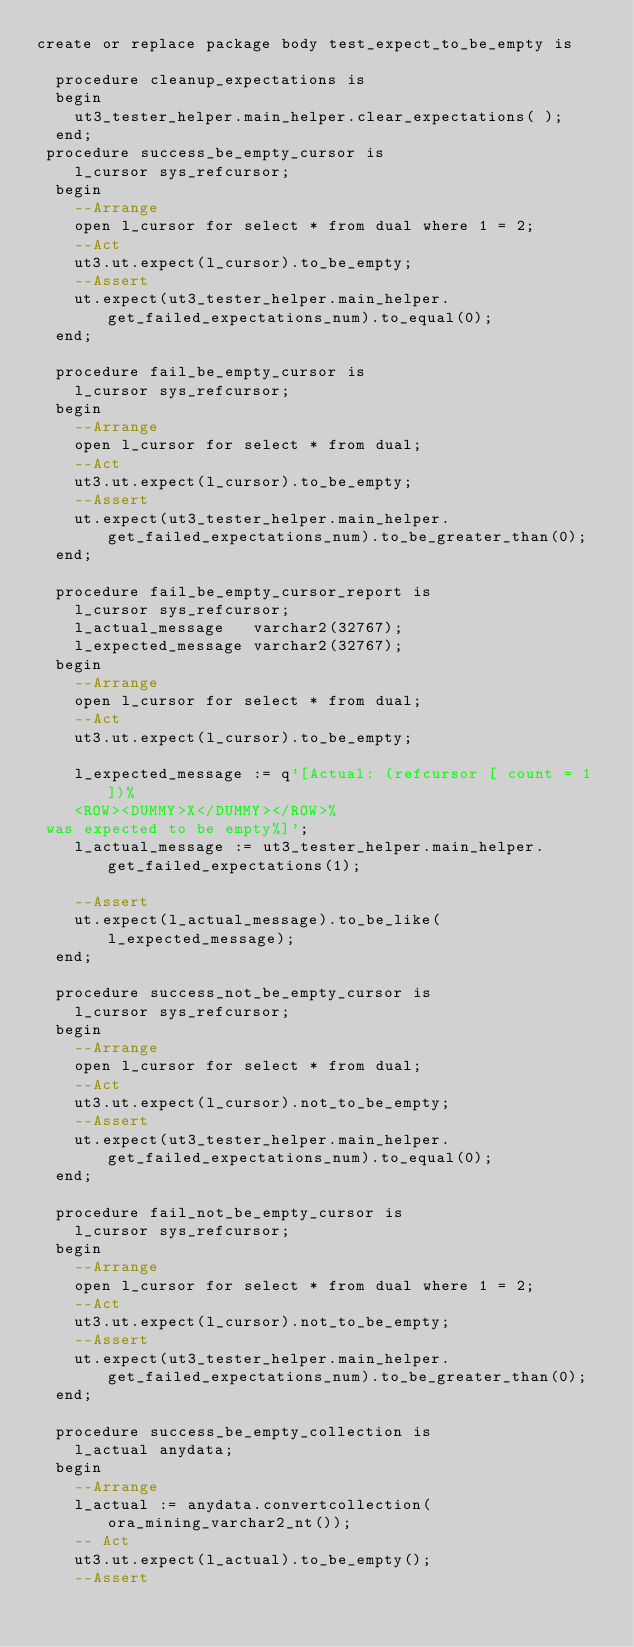<code> <loc_0><loc_0><loc_500><loc_500><_SQL_>create or replace package body test_expect_to_be_empty is

  procedure cleanup_expectations is
  begin
    ut3_tester_helper.main_helper.clear_expectations( );
  end;
 procedure success_be_empty_cursor is
    l_cursor sys_refcursor;
  begin
    --Arrange
    open l_cursor for select * from dual where 1 = 2;
    --Act
    ut3.ut.expect(l_cursor).to_be_empty;
    --Assert
    ut.expect(ut3_tester_helper.main_helper.get_failed_expectations_num).to_equal(0);
  end;

  procedure fail_be_empty_cursor is
    l_cursor sys_refcursor;
  begin
    --Arrange
    open l_cursor for select * from dual;
    --Act
    ut3.ut.expect(l_cursor).to_be_empty;
    --Assert
    ut.expect(ut3_tester_helper.main_helper.get_failed_expectations_num).to_be_greater_than(0);
  end;

  procedure fail_be_empty_cursor_report is
    l_cursor sys_refcursor;
    l_actual_message   varchar2(32767);
    l_expected_message varchar2(32767);
  begin
    --Arrange
    open l_cursor for select * from dual;
    --Act
    ut3.ut.expect(l_cursor).to_be_empty;

    l_expected_message := q'[Actual: (refcursor [ count = 1 ])%
    <ROW><DUMMY>X</DUMMY></ROW>%
 was expected to be empty%]';
    l_actual_message := ut3_tester_helper.main_helper.get_failed_expectations(1);

    --Assert
    ut.expect(l_actual_message).to_be_like(l_expected_message);
  end;

  procedure success_not_be_empty_cursor is
    l_cursor sys_refcursor;
  begin
    --Arrange
    open l_cursor for select * from dual;
    --Act
    ut3.ut.expect(l_cursor).not_to_be_empty;
    --Assert
    ut.expect(ut3_tester_helper.main_helper.get_failed_expectations_num).to_equal(0);
  end;

  procedure fail_not_be_empty_cursor is
    l_cursor sys_refcursor;
  begin
    --Arrange
    open l_cursor for select * from dual where 1 = 2;
    --Act
    ut3.ut.expect(l_cursor).not_to_be_empty;
    --Assert
    ut.expect(ut3_tester_helper.main_helper.get_failed_expectations_num).to_be_greater_than(0);
  end;

  procedure success_be_empty_collection is
    l_actual anydata;
  begin
    --Arrange
    l_actual := anydata.convertcollection(ora_mining_varchar2_nt());
    -- Act
    ut3.ut.expect(l_actual).to_be_empty();
    --Assert</code> 